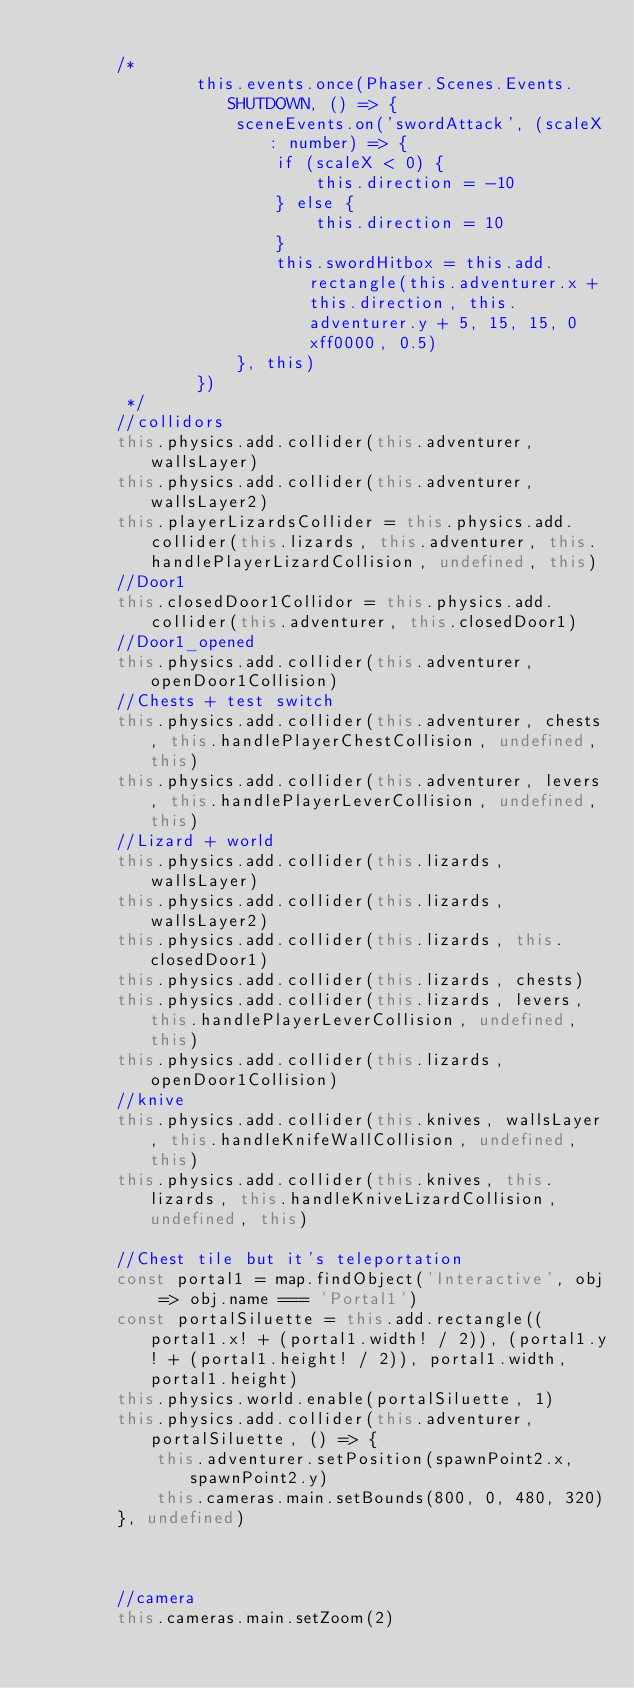<code> <loc_0><loc_0><loc_500><loc_500><_TypeScript_>
        /*
                this.events.once(Phaser.Scenes.Events.SHUTDOWN, () => {
                    sceneEvents.on('swordAttack', (scaleX: number) => {
                        if (scaleX < 0) {
                            this.direction = -10
                        } else {
                            this.direction = 10
                        }
                        this.swordHitbox = this.add.rectangle(this.adventurer.x + this.direction, this.adventurer.y + 5, 15, 15, 0xff0000, 0.5)
                    }, this)
                })
         */
        //collidors
        this.physics.add.collider(this.adventurer, wallsLayer)
        this.physics.add.collider(this.adventurer, wallsLayer2)
        this.playerLizardsCollider = this.physics.add.collider(this.lizards, this.adventurer, this.handlePlayerLizardCollision, undefined, this)
        //Door1
        this.closedDoor1Collidor = this.physics.add.collider(this.adventurer, this.closedDoor1)
        //Door1_opened
        this.physics.add.collider(this.adventurer, openDoor1Collision)
        //Chests + test switch
        this.physics.add.collider(this.adventurer, chests, this.handlePlayerChestCollision, undefined, this)
        this.physics.add.collider(this.adventurer, levers, this.handlePlayerLeverCollision, undefined, this)
        //Lizard + world
        this.physics.add.collider(this.lizards, wallsLayer)
        this.physics.add.collider(this.lizards, wallsLayer2)
        this.physics.add.collider(this.lizards, this.closedDoor1)
        this.physics.add.collider(this.lizards, chests)
        this.physics.add.collider(this.lizards, levers, this.handlePlayerLeverCollision, undefined, this)
        this.physics.add.collider(this.lizards, openDoor1Collision)
        //knive
        this.physics.add.collider(this.knives, wallsLayer, this.handleKnifeWallCollision, undefined, this)
        this.physics.add.collider(this.knives, this.lizards, this.handleKniveLizardCollision, undefined, this)

        //Chest tile but it's teleportation
        const portal1 = map.findObject('Interactive', obj => obj.name === 'Portal1')
        const portalSiluette = this.add.rectangle((portal1.x! + (portal1.width! / 2)), (portal1.y! + (portal1.height! / 2)), portal1.width, portal1.height)
        this.physics.world.enable(portalSiluette, 1)
        this.physics.add.collider(this.adventurer, portalSiluette, () => {
            this.adventurer.setPosition(spawnPoint2.x, spawnPoint2.y)
            this.cameras.main.setBounds(800, 0, 480, 320)
        }, undefined)



        //camera
        this.cameras.main.setZoom(2)</code> 